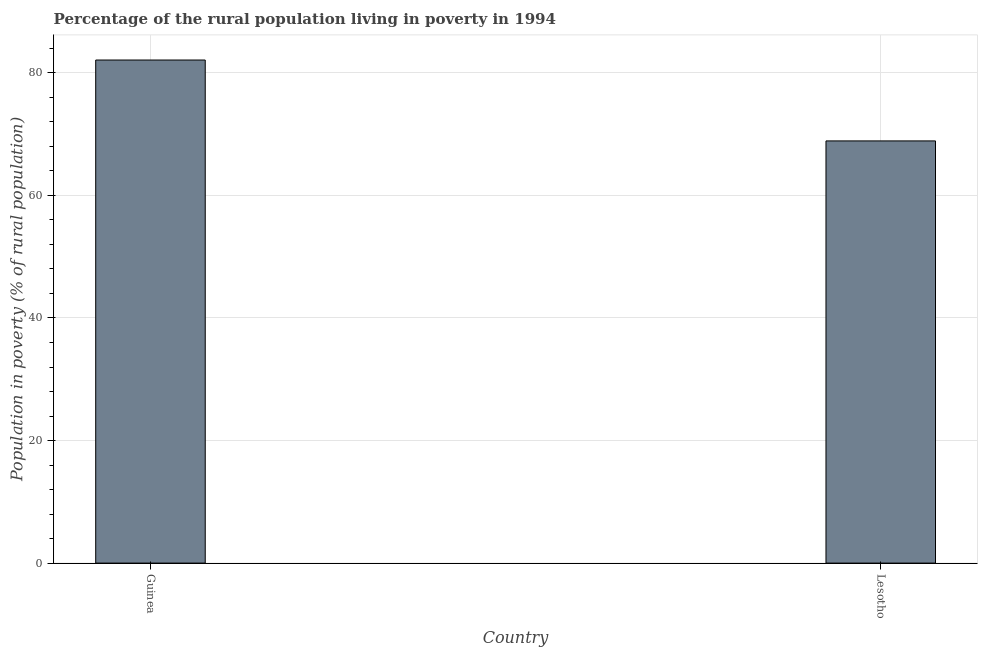Does the graph contain grids?
Ensure brevity in your answer.  Yes. What is the title of the graph?
Give a very brief answer. Percentage of the rural population living in poverty in 1994. What is the label or title of the Y-axis?
Ensure brevity in your answer.  Population in poverty (% of rural population). What is the percentage of rural population living below poverty line in Guinea?
Provide a short and direct response. 82.1. Across all countries, what is the maximum percentage of rural population living below poverty line?
Give a very brief answer. 82.1. Across all countries, what is the minimum percentage of rural population living below poverty line?
Offer a very short reply. 68.9. In which country was the percentage of rural population living below poverty line maximum?
Provide a short and direct response. Guinea. In which country was the percentage of rural population living below poverty line minimum?
Provide a short and direct response. Lesotho. What is the sum of the percentage of rural population living below poverty line?
Ensure brevity in your answer.  151. What is the average percentage of rural population living below poverty line per country?
Provide a short and direct response. 75.5. What is the median percentage of rural population living below poverty line?
Ensure brevity in your answer.  75.5. In how many countries, is the percentage of rural population living below poverty line greater than 60 %?
Give a very brief answer. 2. What is the ratio of the percentage of rural population living below poverty line in Guinea to that in Lesotho?
Offer a very short reply. 1.19. Is the percentage of rural population living below poverty line in Guinea less than that in Lesotho?
Keep it short and to the point. No. What is the difference between two consecutive major ticks on the Y-axis?
Provide a succinct answer. 20. What is the Population in poverty (% of rural population) of Guinea?
Offer a very short reply. 82.1. What is the Population in poverty (% of rural population) of Lesotho?
Keep it short and to the point. 68.9. What is the ratio of the Population in poverty (% of rural population) in Guinea to that in Lesotho?
Provide a succinct answer. 1.19. 